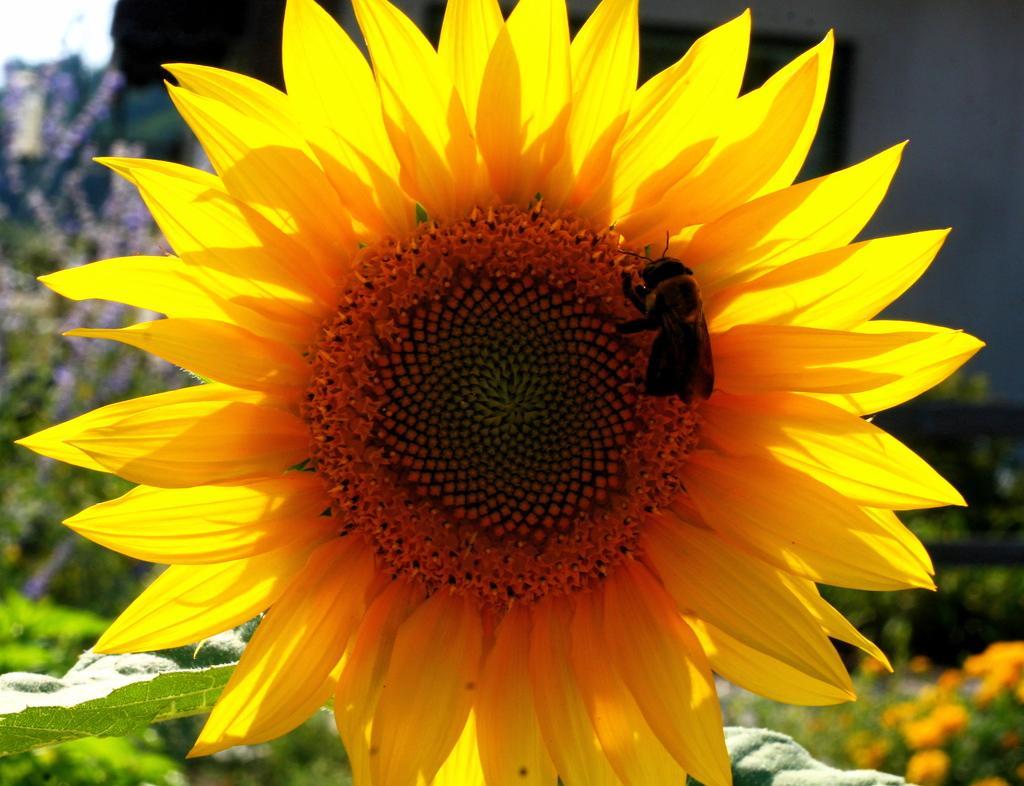Could you give a brief overview of what you see in this image? In the center of the image, we can see an insect on the sunflower and in the background, there are plants and flowers. 